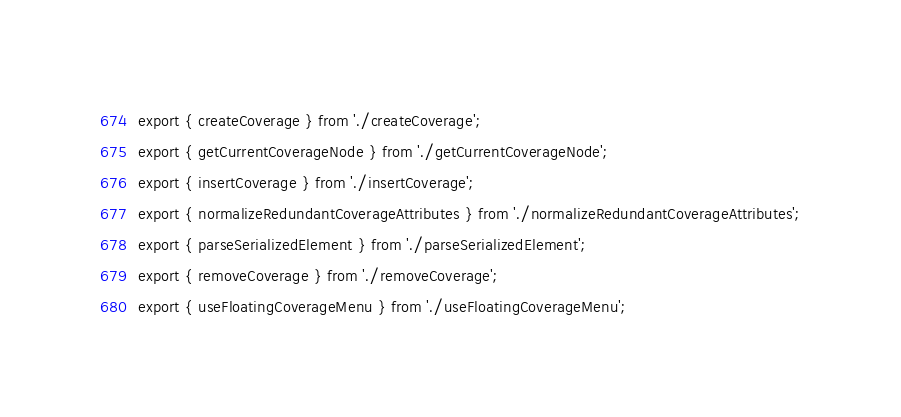Convert code to text. <code><loc_0><loc_0><loc_500><loc_500><_TypeScript_>export { createCoverage } from './createCoverage';
export { getCurrentCoverageNode } from './getCurrentCoverageNode';
export { insertCoverage } from './insertCoverage';
export { normalizeRedundantCoverageAttributes } from './normalizeRedundantCoverageAttributes';
export { parseSerializedElement } from './parseSerializedElement';
export { removeCoverage } from './removeCoverage';
export { useFloatingCoverageMenu } from './useFloatingCoverageMenu';
</code> 